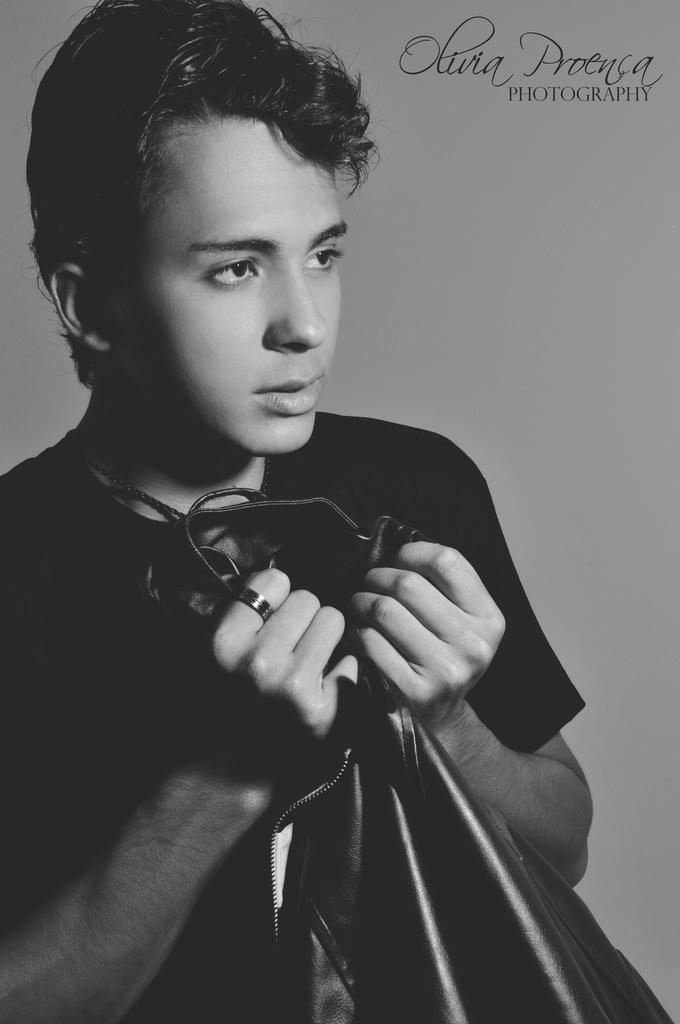How would you summarize this image in a sentence or two? There is a boy in a t-shirt, holding a jacket with both hands. In the right top corner, there is a watermark. In the background, there is wall. 